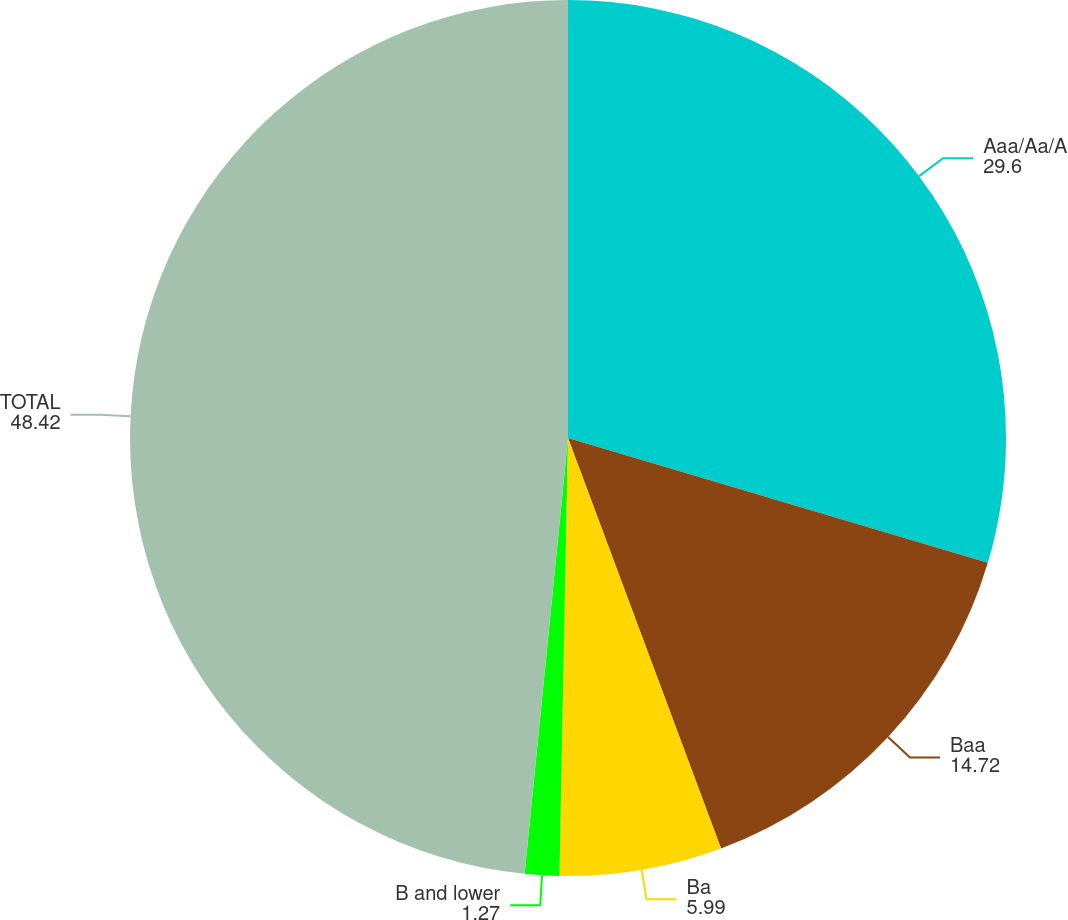Convert chart to OTSL. <chart><loc_0><loc_0><loc_500><loc_500><pie_chart><fcel>Aaa/Aa/A<fcel>Baa<fcel>Ba<fcel>B and lower<fcel>TOTAL<nl><fcel>29.6%<fcel>14.72%<fcel>5.99%<fcel>1.27%<fcel>48.42%<nl></chart> 